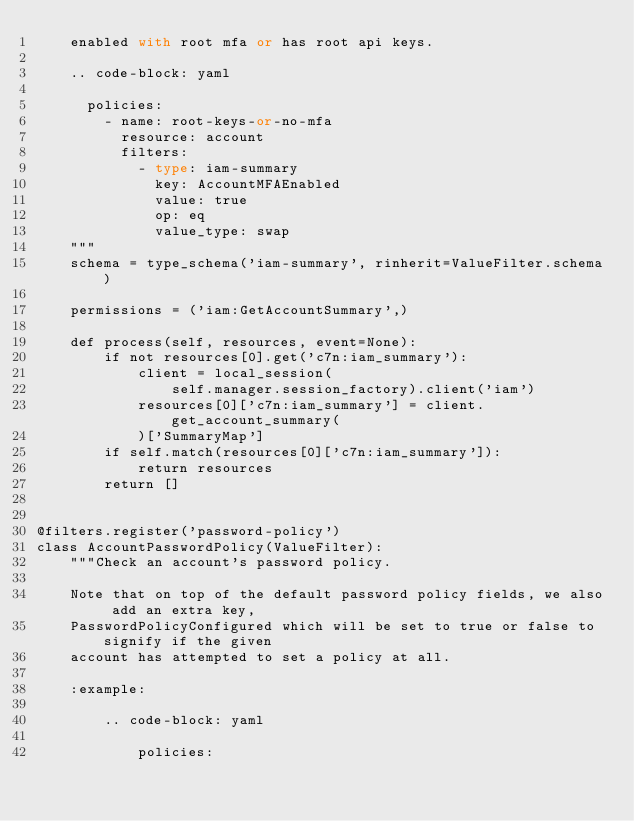Convert code to text. <code><loc_0><loc_0><loc_500><loc_500><_Python_>    enabled with root mfa or has root api keys.

    .. code-block: yaml

      policies:
        - name: root-keys-or-no-mfa
          resource: account
          filters:
            - type: iam-summary
              key: AccountMFAEnabled
              value: true
              op: eq
              value_type: swap
    """
    schema = type_schema('iam-summary', rinherit=ValueFilter.schema)

    permissions = ('iam:GetAccountSummary',)

    def process(self, resources, event=None):
        if not resources[0].get('c7n:iam_summary'):
            client = local_session(
                self.manager.session_factory).client('iam')
            resources[0]['c7n:iam_summary'] = client.get_account_summary(
            )['SummaryMap']
        if self.match(resources[0]['c7n:iam_summary']):
            return resources
        return []


@filters.register('password-policy')
class AccountPasswordPolicy(ValueFilter):
    """Check an account's password policy.

    Note that on top of the default password policy fields, we also add an extra key,
    PasswordPolicyConfigured which will be set to true or false to signify if the given
    account has attempted to set a policy at all.

    :example:

        .. code-block: yaml

            policies:</code> 